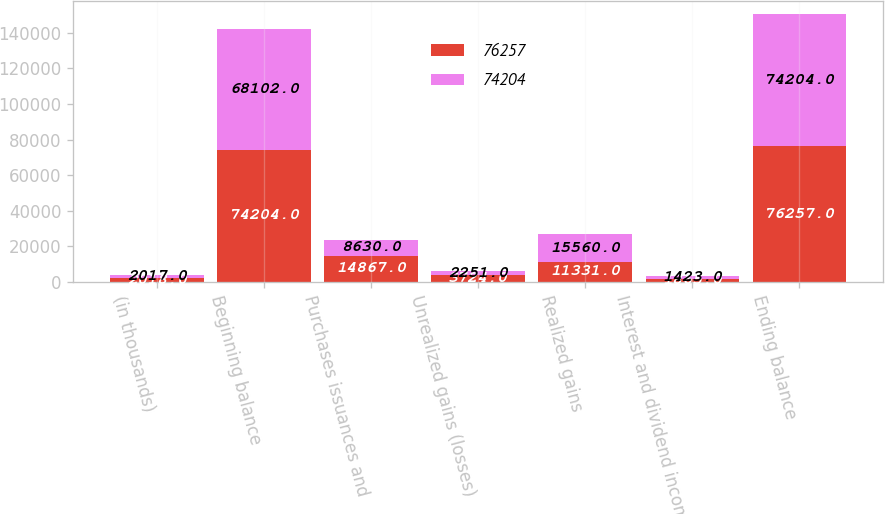Convert chart to OTSL. <chart><loc_0><loc_0><loc_500><loc_500><stacked_bar_chart><ecel><fcel>(in thousands)<fcel>Beginning balance<fcel>Purchases issuances and<fcel>Unrealized gains (losses)<fcel>Realized gains<fcel>Interest and dividend income<fcel>Ending balance<nl><fcel>76257<fcel>2018<fcel>74204<fcel>14867<fcel>3724<fcel>11331<fcel>1865<fcel>76257<nl><fcel>74204<fcel>2017<fcel>68102<fcel>8630<fcel>2251<fcel>15560<fcel>1423<fcel>74204<nl></chart> 